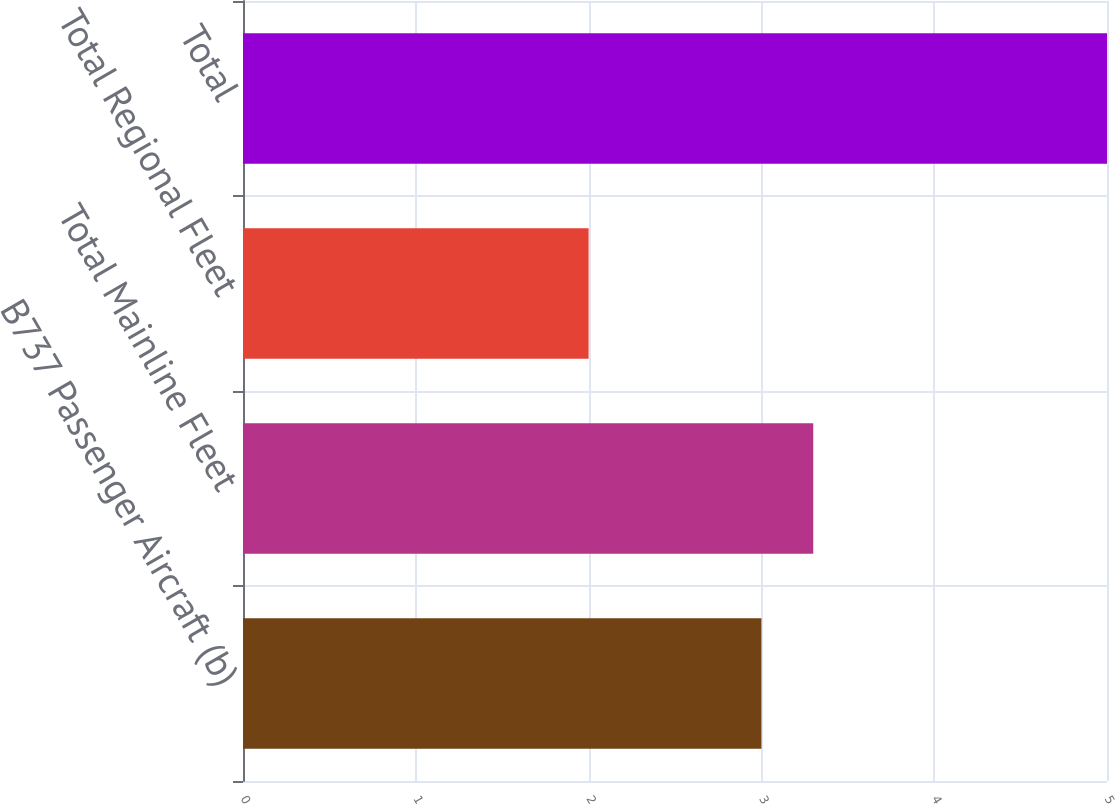Convert chart. <chart><loc_0><loc_0><loc_500><loc_500><bar_chart><fcel>B737 Passenger Aircraft (b)<fcel>Total Mainline Fleet<fcel>Total Regional Fleet<fcel>Total<nl><fcel>3<fcel>3.3<fcel>2<fcel>5<nl></chart> 